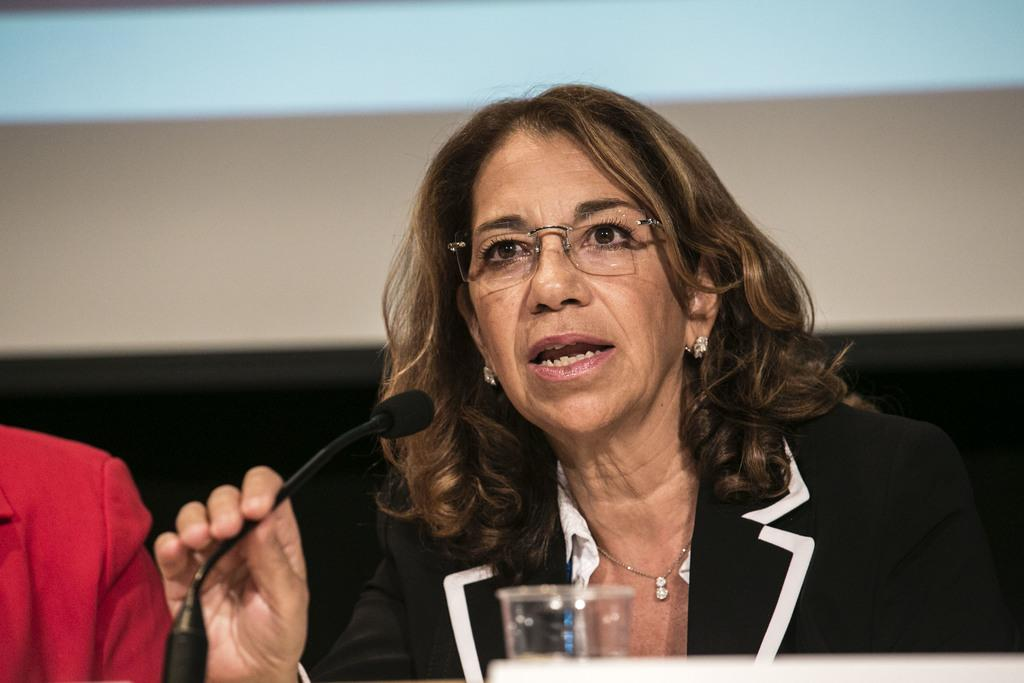Who is the main subject in the image? There is a woman in the image. What is the woman doing in the image? The woman is speaking on a microphone. Can you describe the woman's appearance? The woman is wearing spectacles. What object is in front of the woman? There is a glass in front of the woman. Where is the cushion located in the image? There is no cushion present in the image. What type of mitten is the woman wearing in the image? The woman is not wearing a mitten in the image; she is wearing spectacles. 